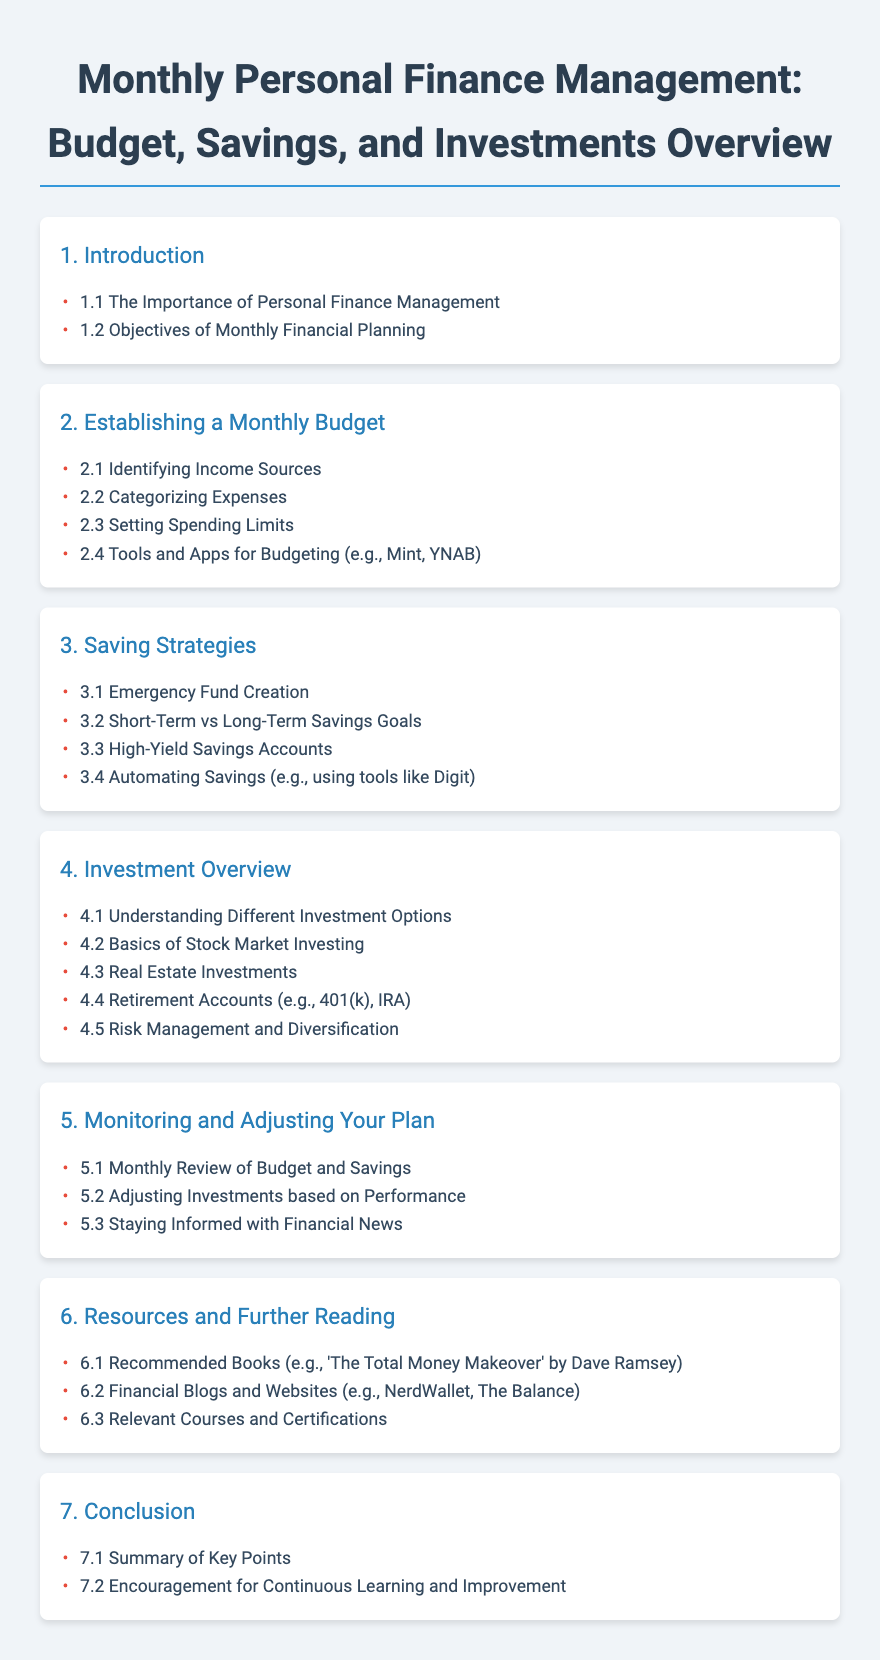What is the title of the document? The title is prominently displayed at the top, indicating the focus of the content.
Answer: Monthly Personal Finance Management: Budget, Savings, and Investments Overview What is the first subsection under the Introduction? The subsections are listed under the section titles, indicating their order.
Answer: The Importance of Personal Finance Management How many main sections are in the document? The sections are numbered, providing a clear count of the main topics covered.
Answer: 7 Which tool is mentioned for budgeting? The document provides examples of tools in the relevant subsection.
Answer: Mint What type of savings account is highlighted in the Savings Strategies section? Specific types of savings accounts are mentioned under the Saving Strategies section.
Answer: High-Yield Savings Accounts What is the primary goal of establishing a budget? The objectives are outlined in the document, indicating the purpose of budgeting.
Answer: Setting Spending Limits How often should you review your budget according to the document? The section on monitoring suggests a regular frequency for budget reviews.
Answer: Monthly What book is recommended for further reading? Recommended resources are listed, including books relevant to personal finance.
Answer: The Total Money Makeover What is indicated as a key aspect of investment management? The specific considerations for investments are addressed in that section of the document.
Answer: Risk Management and Diversification 